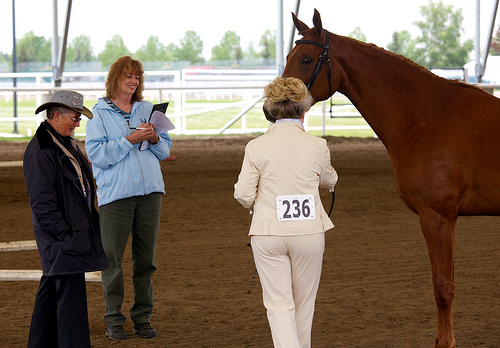<image>
Can you confirm if the number is on the horse? No. The number is not positioned on the horse. They may be near each other, but the number is not supported by or resting on top of the horse. 